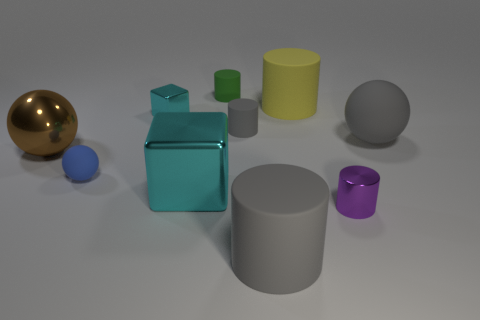Can you describe the colors of the objects in the image? Certainly! Starting from the left, there's a shiny gold sphere, a small blue sphere, and a metallic cyan cube. Next, there's a smaller green cylinder, a tall yellow cylinder, a dark grey sphere, and finally, a large light grey cylinder paired with a small purple cylinder. 